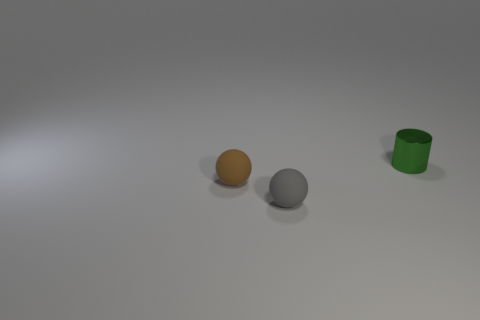What is the shape of the tiny object that is behind the brown thing?
Provide a succinct answer. Cylinder. What size is the thing on the left side of the gray ball?
Your answer should be very brief. Small. There is a green thing that is the same size as the gray rubber object; what is it made of?
Ensure brevity in your answer.  Metal. Does the green object have the same shape as the gray object?
Provide a short and direct response. No. How many things are either tiny objects or spheres right of the brown rubber thing?
Your response must be concise. 3. There is a matte object behind the gray object; is its size the same as the small cylinder?
Keep it short and to the point. Yes. There is a tiny matte sphere in front of the tiny matte thing that is on the left side of the gray thing; what number of gray things are to the left of it?
Offer a very short reply. 0. What number of green things are either tiny metal cylinders or tiny things?
Offer a terse response. 1. There is a sphere that is made of the same material as the gray thing; what is its color?
Your answer should be very brief. Brown. How many large things are brown shiny blocks or green metallic things?
Ensure brevity in your answer.  0. 